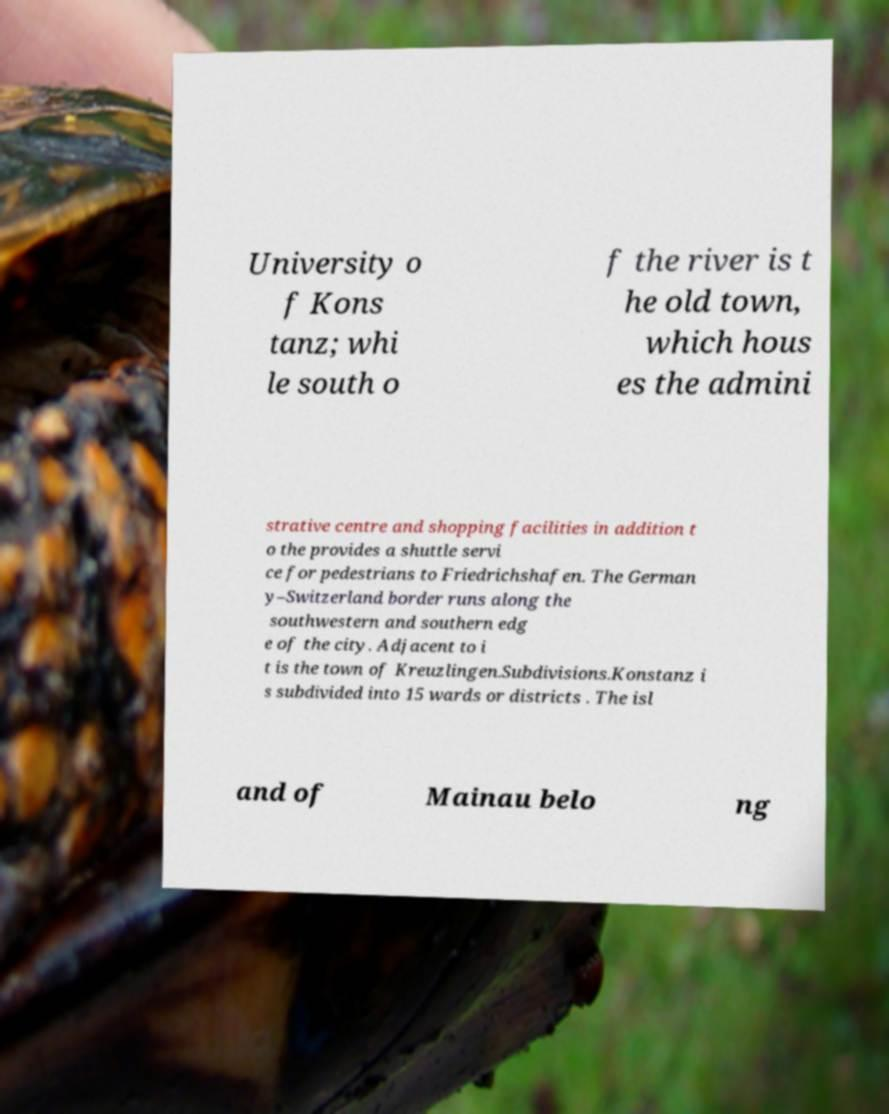Can you read and provide the text displayed in the image?This photo seems to have some interesting text. Can you extract and type it out for me? University o f Kons tanz; whi le south o f the river is t he old town, which hous es the admini strative centre and shopping facilities in addition t o the provides a shuttle servi ce for pedestrians to Friedrichshafen. The German y–Switzerland border runs along the southwestern and southern edg e of the city. Adjacent to i t is the town of Kreuzlingen.Subdivisions.Konstanz i s subdivided into 15 wards or districts . The isl and of Mainau belo ng 